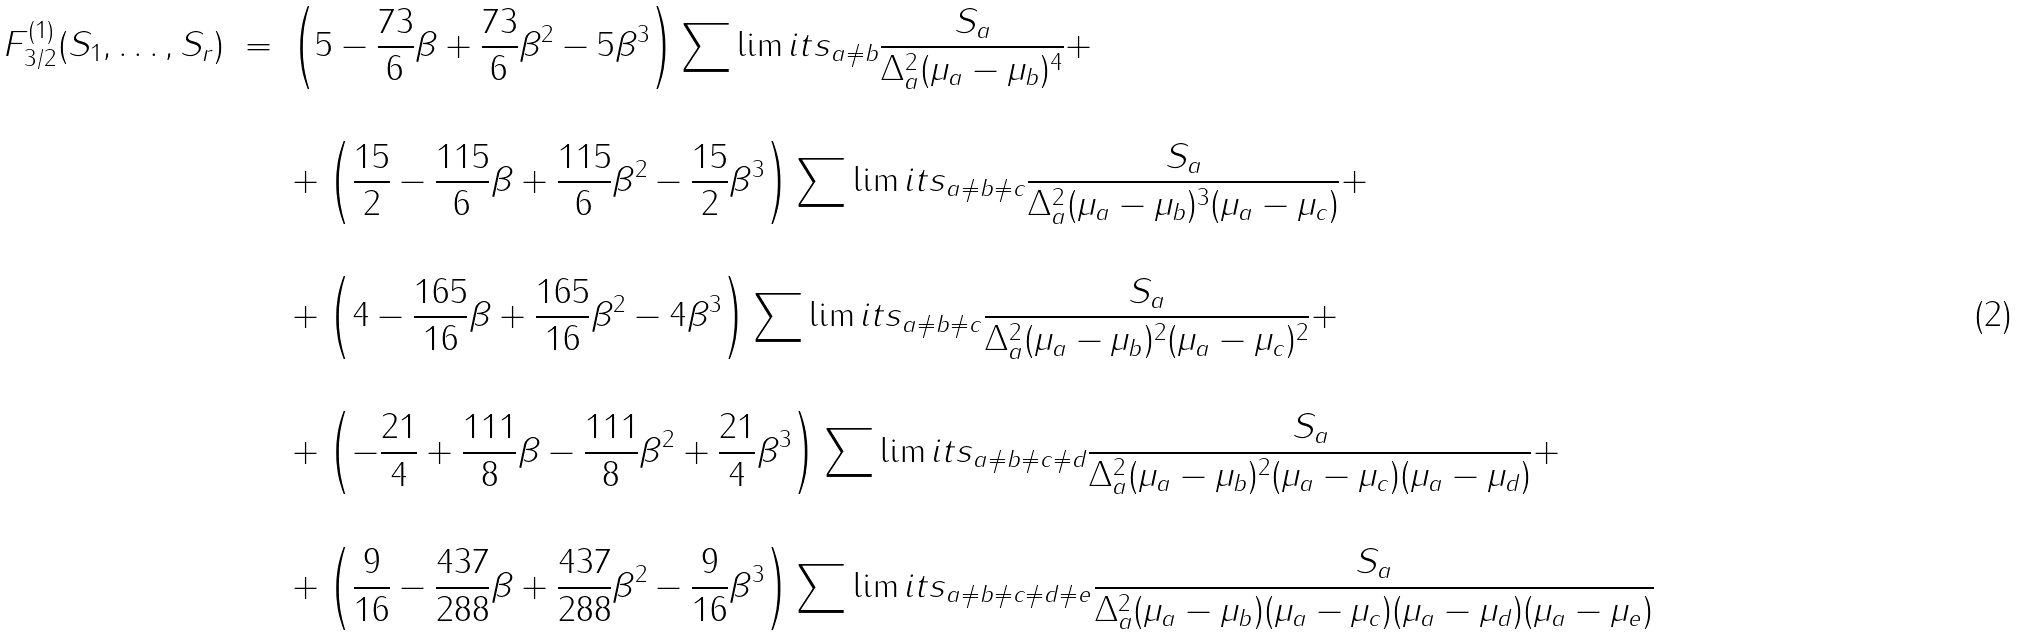Convert formula to latex. <formula><loc_0><loc_0><loc_500><loc_500>F ^ { ( 1 ) } _ { 3 / 2 } ( S _ { 1 } , \dots , S _ { r } ) \ = \ & \left ( 5 - \frac { 7 3 } { 6 } \beta + \frac { 7 3 } { 6 } \beta ^ { 2 } - 5 \beta ^ { 3 } \right ) \sum \lim i t s _ { a \neq b } \frac { S _ { a } } { \Delta _ { a } ^ { 2 } ( \mu _ { a } - \mu _ { b } ) ^ { 4 } } + \\ & \\ & + \left ( \frac { 1 5 } { 2 } - \frac { 1 1 5 } { 6 } \beta + \frac { 1 1 5 } { 6 } \beta ^ { 2 } - \frac { 1 5 } { 2 } \beta ^ { 3 } \right ) \sum \lim i t s _ { a \neq b \neq c } \frac { S _ { a } } { \Delta _ { a } ^ { 2 } ( \mu _ { a } - \mu _ { b } ) ^ { 3 } ( \mu _ { a } - \mu _ { c } ) } + \\ & \\ & + \left ( 4 - \frac { 1 6 5 } { 1 6 } \beta + \frac { 1 6 5 } { 1 6 } \beta ^ { 2 } - 4 \beta ^ { 3 } \right ) \sum \lim i t s _ { a \neq b \neq c } \frac { S _ { a } } { \Delta _ { a } ^ { 2 } ( \mu _ { a } - \mu _ { b } ) ^ { 2 } ( \mu _ { a } - \mu _ { c } ) ^ { 2 } } + \\ & \\ & + \left ( - \frac { 2 1 } { 4 } + \frac { 1 1 1 } { 8 } \beta - \frac { 1 1 1 } { 8 } \beta ^ { 2 } + \frac { 2 1 } { 4 } \beta ^ { 3 } \right ) \sum \lim i t s _ { a \neq b \neq c \neq d } \frac { S _ { a } } { \Delta _ { a } ^ { 2 } ( \mu _ { a } - \mu _ { b } ) ^ { 2 } ( \mu _ { a } - \mu _ { c } ) ( \mu _ { a } - \mu _ { d } ) } + \\ & \\ & + \left ( \frac { 9 } { 1 6 } - \frac { 4 3 7 } { 2 8 8 } \beta + \frac { 4 3 7 } { 2 8 8 } \beta ^ { 2 } - \frac { 9 } { 1 6 } \beta ^ { 3 } \right ) \sum \lim i t s _ { a \neq b \neq c \neq d \neq e } \frac { S _ { a } } { \Delta _ { a } ^ { 2 } ( \mu _ { a } - \mu _ { b } ) ( \mu _ { a } - \mu _ { c } ) ( \mu _ { a } - \mu _ { d } ) ( \mu _ { a } - \mu _ { e } ) }</formula> 